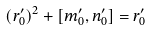<formula> <loc_0><loc_0><loc_500><loc_500>( r ^ { \prime } _ { 0 } ) ^ { 2 } + [ m ^ { \prime } _ { 0 } , n ^ { \prime } _ { 0 } ] = r ^ { \prime } _ { 0 }</formula> 